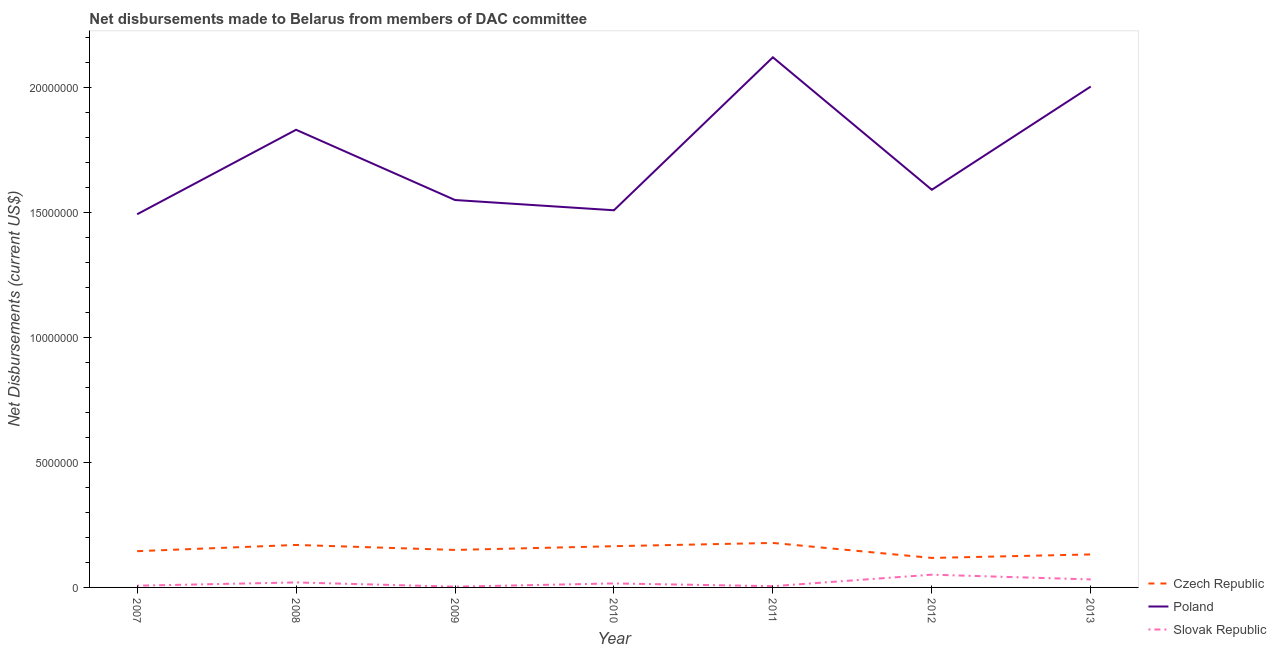How many different coloured lines are there?
Provide a succinct answer. 3. Is the number of lines equal to the number of legend labels?
Keep it short and to the point. Yes. What is the net disbursements made by slovak republic in 2009?
Keep it short and to the point. 3.00e+04. Across all years, what is the maximum net disbursements made by czech republic?
Your answer should be very brief. 1.78e+06. Across all years, what is the minimum net disbursements made by czech republic?
Your answer should be very brief. 1.18e+06. In which year was the net disbursements made by poland maximum?
Keep it short and to the point. 2011. What is the total net disbursements made by slovak republic in the graph?
Make the answer very short. 1.34e+06. What is the difference between the net disbursements made by czech republic in 2008 and that in 2013?
Your answer should be very brief. 3.80e+05. What is the difference between the net disbursements made by slovak republic in 2012 and the net disbursements made by poland in 2011?
Provide a short and direct response. -2.07e+07. What is the average net disbursements made by slovak republic per year?
Offer a terse response. 1.91e+05. In the year 2011, what is the difference between the net disbursements made by slovak republic and net disbursements made by poland?
Keep it short and to the point. -2.12e+07. In how many years, is the net disbursements made by poland greater than 11000000 US$?
Provide a succinct answer. 7. What is the ratio of the net disbursements made by slovak republic in 2007 to that in 2013?
Your answer should be compact. 0.22. Is the net disbursements made by slovak republic in 2010 less than that in 2012?
Your response must be concise. Yes. What is the difference between the highest and the lowest net disbursements made by slovak republic?
Offer a very short reply. 4.80e+05. Is the sum of the net disbursements made by czech republic in 2007 and 2013 greater than the maximum net disbursements made by poland across all years?
Offer a terse response. No. Is it the case that in every year, the sum of the net disbursements made by czech republic and net disbursements made by poland is greater than the net disbursements made by slovak republic?
Your answer should be very brief. Yes. Is the net disbursements made by slovak republic strictly greater than the net disbursements made by poland over the years?
Provide a succinct answer. No. Is the net disbursements made by poland strictly less than the net disbursements made by czech republic over the years?
Keep it short and to the point. No. How many lines are there?
Your answer should be very brief. 3. What is the difference between two consecutive major ticks on the Y-axis?
Keep it short and to the point. 5.00e+06. Are the values on the major ticks of Y-axis written in scientific E-notation?
Make the answer very short. No. Does the graph contain any zero values?
Give a very brief answer. No. Does the graph contain grids?
Provide a succinct answer. No. How are the legend labels stacked?
Offer a very short reply. Vertical. What is the title of the graph?
Your response must be concise. Net disbursements made to Belarus from members of DAC committee. What is the label or title of the X-axis?
Provide a succinct answer. Year. What is the label or title of the Y-axis?
Provide a succinct answer. Net Disbursements (current US$). What is the Net Disbursements (current US$) in Czech Republic in 2007?
Offer a very short reply. 1.45e+06. What is the Net Disbursements (current US$) in Poland in 2007?
Provide a succinct answer. 1.49e+07. What is the Net Disbursements (current US$) in Slovak Republic in 2007?
Provide a succinct answer. 7.00e+04. What is the Net Disbursements (current US$) in Czech Republic in 2008?
Ensure brevity in your answer.  1.70e+06. What is the Net Disbursements (current US$) in Poland in 2008?
Keep it short and to the point. 1.83e+07. What is the Net Disbursements (current US$) in Czech Republic in 2009?
Your response must be concise. 1.50e+06. What is the Net Disbursements (current US$) in Poland in 2009?
Offer a terse response. 1.55e+07. What is the Net Disbursements (current US$) of Slovak Republic in 2009?
Your answer should be compact. 3.00e+04. What is the Net Disbursements (current US$) in Czech Republic in 2010?
Provide a succinct answer. 1.65e+06. What is the Net Disbursements (current US$) in Poland in 2010?
Your answer should be very brief. 1.51e+07. What is the Net Disbursements (current US$) of Slovak Republic in 2010?
Give a very brief answer. 1.60e+05. What is the Net Disbursements (current US$) in Czech Republic in 2011?
Provide a succinct answer. 1.78e+06. What is the Net Disbursements (current US$) in Poland in 2011?
Provide a succinct answer. 2.12e+07. What is the Net Disbursements (current US$) of Czech Republic in 2012?
Provide a short and direct response. 1.18e+06. What is the Net Disbursements (current US$) of Poland in 2012?
Provide a short and direct response. 1.59e+07. What is the Net Disbursements (current US$) of Slovak Republic in 2012?
Make the answer very short. 5.10e+05. What is the Net Disbursements (current US$) in Czech Republic in 2013?
Provide a short and direct response. 1.32e+06. What is the Net Disbursements (current US$) in Poland in 2013?
Your answer should be compact. 2.00e+07. Across all years, what is the maximum Net Disbursements (current US$) in Czech Republic?
Keep it short and to the point. 1.78e+06. Across all years, what is the maximum Net Disbursements (current US$) of Poland?
Ensure brevity in your answer.  2.12e+07. Across all years, what is the maximum Net Disbursements (current US$) in Slovak Republic?
Provide a short and direct response. 5.10e+05. Across all years, what is the minimum Net Disbursements (current US$) of Czech Republic?
Keep it short and to the point. 1.18e+06. Across all years, what is the minimum Net Disbursements (current US$) of Poland?
Provide a succinct answer. 1.49e+07. What is the total Net Disbursements (current US$) of Czech Republic in the graph?
Provide a short and direct response. 1.06e+07. What is the total Net Disbursements (current US$) of Poland in the graph?
Provide a short and direct response. 1.21e+08. What is the total Net Disbursements (current US$) of Slovak Republic in the graph?
Your response must be concise. 1.34e+06. What is the difference between the Net Disbursements (current US$) of Czech Republic in 2007 and that in 2008?
Your answer should be compact. -2.50e+05. What is the difference between the Net Disbursements (current US$) in Poland in 2007 and that in 2008?
Provide a short and direct response. -3.38e+06. What is the difference between the Net Disbursements (current US$) in Czech Republic in 2007 and that in 2009?
Offer a very short reply. -5.00e+04. What is the difference between the Net Disbursements (current US$) of Poland in 2007 and that in 2009?
Your answer should be very brief. -5.70e+05. What is the difference between the Net Disbursements (current US$) in Poland in 2007 and that in 2010?
Your answer should be compact. -1.60e+05. What is the difference between the Net Disbursements (current US$) in Slovak Republic in 2007 and that in 2010?
Give a very brief answer. -9.00e+04. What is the difference between the Net Disbursements (current US$) in Czech Republic in 2007 and that in 2011?
Give a very brief answer. -3.30e+05. What is the difference between the Net Disbursements (current US$) of Poland in 2007 and that in 2011?
Your response must be concise. -6.28e+06. What is the difference between the Net Disbursements (current US$) in Slovak Republic in 2007 and that in 2011?
Your answer should be very brief. 2.00e+04. What is the difference between the Net Disbursements (current US$) in Poland in 2007 and that in 2012?
Keep it short and to the point. -9.80e+05. What is the difference between the Net Disbursements (current US$) in Slovak Republic in 2007 and that in 2012?
Provide a succinct answer. -4.40e+05. What is the difference between the Net Disbursements (current US$) of Czech Republic in 2007 and that in 2013?
Ensure brevity in your answer.  1.30e+05. What is the difference between the Net Disbursements (current US$) in Poland in 2007 and that in 2013?
Your answer should be compact. -5.11e+06. What is the difference between the Net Disbursements (current US$) in Slovak Republic in 2007 and that in 2013?
Your answer should be very brief. -2.50e+05. What is the difference between the Net Disbursements (current US$) in Poland in 2008 and that in 2009?
Offer a terse response. 2.81e+06. What is the difference between the Net Disbursements (current US$) of Poland in 2008 and that in 2010?
Your answer should be very brief. 3.22e+06. What is the difference between the Net Disbursements (current US$) in Czech Republic in 2008 and that in 2011?
Ensure brevity in your answer.  -8.00e+04. What is the difference between the Net Disbursements (current US$) of Poland in 2008 and that in 2011?
Your answer should be very brief. -2.90e+06. What is the difference between the Net Disbursements (current US$) of Czech Republic in 2008 and that in 2012?
Ensure brevity in your answer.  5.20e+05. What is the difference between the Net Disbursements (current US$) in Poland in 2008 and that in 2012?
Your answer should be compact. 2.40e+06. What is the difference between the Net Disbursements (current US$) of Slovak Republic in 2008 and that in 2012?
Ensure brevity in your answer.  -3.10e+05. What is the difference between the Net Disbursements (current US$) of Poland in 2008 and that in 2013?
Your answer should be very brief. -1.73e+06. What is the difference between the Net Disbursements (current US$) in Slovak Republic in 2008 and that in 2013?
Make the answer very short. -1.20e+05. What is the difference between the Net Disbursements (current US$) in Czech Republic in 2009 and that in 2010?
Keep it short and to the point. -1.50e+05. What is the difference between the Net Disbursements (current US$) of Poland in 2009 and that in 2010?
Make the answer very short. 4.10e+05. What is the difference between the Net Disbursements (current US$) in Czech Republic in 2009 and that in 2011?
Offer a very short reply. -2.80e+05. What is the difference between the Net Disbursements (current US$) of Poland in 2009 and that in 2011?
Make the answer very short. -5.71e+06. What is the difference between the Net Disbursements (current US$) of Czech Republic in 2009 and that in 2012?
Your answer should be very brief. 3.20e+05. What is the difference between the Net Disbursements (current US$) in Poland in 2009 and that in 2012?
Provide a short and direct response. -4.10e+05. What is the difference between the Net Disbursements (current US$) of Slovak Republic in 2009 and that in 2012?
Offer a terse response. -4.80e+05. What is the difference between the Net Disbursements (current US$) in Poland in 2009 and that in 2013?
Keep it short and to the point. -4.54e+06. What is the difference between the Net Disbursements (current US$) of Poland in 2010 and that in 2011?
Your answer should be very brief. -6.12e+06. What is the difference between the Net Disbursements (current US$) in Slovak Republic in 2010 and that in 2011?
Make the answer very short. 1.10e+05. What is the difference between the Net Disbursements (current US$) of Poland in 2010 and that in 2012?
Make the answer very short. -8.20e+05. What is the difference between the Net Disbursements (current US$) of Slovak Republic in 2010 and that in 2012?
Keep it short and to the point. -3.50e+05. What is the difference between the Net Disbursements (current US$) in Czech Republic in 2010 and that in 2013?
Provide a short and direct response. 3.30e+05. What is the difference between the Net Disbursements (current US$) of Poland in 2010 and that in 2013?
Your response must be concise. -4.95e+06. What is the difference between the Net Disbursements (current US$) in Czech Republic in 2011 and that in 2012?
Offer a very short reply. 6.00e+05. What is the difference between the Net Disbursements (current US$) of Poland in 2011 and that in 2012?
Your answer should be very brief. 5.30e+06. What is the difference between the Net Disbursements (current US$) in Slovak Republic in 2011 and that in 2012?
Offer a terse response. -4.60e+05. What is the difference between the Net Disbursements (current US$) in Poland in 2011 and that in 2013?
Your answer should be compact. 1.17e+06. What is the difference between the Net Disbursements (current US$) in Poland in 2012 and that in 2013?
Provide a succinct answer. -4.13e+06. What is the difference between the Net Disbursements (current US$) of Czech Republic in 2007 and the Net Disbursements (current US$) of Poland in 2008?
Provide a short and direct response. -1.69e+07. What is the difference between the Net Disbursements (current US$) in Czech Republic in 2007 and the Net Disbursements (current US$) in Slovak Republic in 2008?
Your answer should be compact. 1.25e+06. What is the difference between the Net Disbursements (current US$) in Poland in 2007 and the Net Disbursements (current US$) in Slovak Republic in 2008?
Keep it short and to the point. 1.47e+07. What is the difference between the Net Disbursements (current US$) in Czech Republic in 2007 and the Net Disbursements (current US$) in Poland in 2009?
Your answer should be compact. -1.40e+07. What is the difference between the Net Disbursements (current US$) in Czech Republic in 2007 and the Net Disbursements (current US$) in Slovak Republic in 2009?
Provide a short and direct response. 1.42e+06. What is the difference between the Net Disbursements (current US$) of Poland in 2007 and the Net Disbursements (current US$) of Slovak Republic in 2009?
Give a very brief answer. 1.49e+07. What is the difference between the Net Disbursements (current US$) in Czech Republic in 2007 and the Net Disbursements (current US$) in Poland in 2010?
Provide a short and direct response. -1.36e+07. What is the difference between the Net Disbursements (current US$) of Czech Republic in 2007 and the Net Disbursements (current US$) of Slovak Republic in 2010?
Keep it short and to the point. 1.29e+06. What is the difference between the Net Disbursements (current US$) in Poland in 2007 and the Net Disbursements (current US$) in Slovak Republic in 2010?
Ensure brevity in your answer.  1.48e+07. What is the difference between the Net Disbursements (current US$) of Czech Republic in 2007 and the Net Disbursements (current US$) of Poland in 2011?
Your response must be concise. -1.98e+07. What is the difference between the Net Disbursements (current US$) of Czech Republic in 2007 and the Net Disbursements (current US$) of Slovak Republic in 2011?
Offer a terse response. 1.40e+06. What is the difference between the Net Disbursements (current US$) of Poland in 2007 and the Net Disbursements (current US$) of Slovak Republic in 2011?
Offer a terse response. 1.49e+07. What is the difference between the Net Disbursements (current US$) of Czech Republic in 2007 and the Net Disbursements (current US$) of Poland in 2012?
Give a very brief answer. -1.45e+07. What is the difference between the Net Disbursements (current US$) of Czech Republic in 2007 and the Net Disbursements (current US$) of Slovak Republic in 2012?
Provide a succinct answer. 9.40e+05. What is the difference between the Net Disbursements (current US$) of Poland in 2007 and the Net Disbursements (current US$) of Slovak Republic in 2012?
Provide a short and direct response. 1.44e+07. What is the difference between the Net Disbursements (current US$) of Czech Republic in 2007 and the Net Disbursements (current US$) of Poland in 2013?
Your response must be concise. -1.86e+07. What is the difference between the Net Disbursements (current US$) in Czech Republic in 2007 and the Net Disbursements (current US$) in Slovak Republic in 2013?
Offer a very short reply. 1.13e+06. What is the difference between the Net Disbursements (current US$) of Poland in 2007 and the Net Disbursements (current US$) of Slovak Republic in 2013?
Give a very brief answer. 1.46e+07. What is the difference between the Net Disbursements (current US$) in Czech Republic in 2008 and the Net Disbursements (current US$) in Poland in 2009?
Keep it short and to the point. -1.38e+07. What is the difference between the Net Disbursements (current US$) in Czech Republic in 2008 and the Net Disbursements (current US$) in Slovak Republic in 2009?
Offer a very short reply. 1.67e+06. What is the difference between the Net Disbursements (current US$) of Poland in 2008 and the Net Disbursements (current US$) of Slovak Republic in 2009?
Ensure brevity in your answer.  1.83e+07. What is the difference between the Net Disbursements (current US$) of Czech Republic in 2008 and the Net Disbursements (current US$) of Poland in 2010?
Give a very brief answer. -1.34e+07. What is the difference between the Net Disbursements (current US$) of Czech Republic in 2008 and the Net Disbursements (current US$) of Slovak Republic in 2010?
Give a very brief answer. 1.54e+06. What is the difference between the Net Disbursements (current US$) in Poland in 2008 and the Net Disbursements (current US$) in Slovak Republic in 2010?
Provide a succinct answer. 1.82e+07. What is the difference between the Net Disbursements (current US$) of Czech Republic in 2008 and the Net Disbursements (current US$) of Poland in 2011?
Provide a succinct answer. -1.95e+07. What is the difference between the Net Disbursements (current US$) in Czech Republic in 2008 and the Net Disbursements (current US$) in Slovak Republic in 2011?
Give a very brief answer. 1.65e+06. What is the difference between the Net Disbursements (current US$) of Poland in 2008 and the Net Disbursements (current US$) of Slovak Republic in 2011?
Give a very brief answer. 1.83e+07. What is the difference between the Net Disbursements (current US$) in Czech Republic in 2008 and the Net Disbursements (current US$) in Poland in 2012?
Your answer should be very brief. -1.42e+07. What is the difference between the Net Disbursements (current US$) in Czech Republic in 2008 and the Net Disbursements (current US$) in Slovak Republic in 2012?
Ensure brevity in your answer.  1.19e+06. What is the difference between the Net Disbursements (current US$) in Poland in 2008 and the Net Disbursements (current US$) in Slovak Republic in 2012?
Your answer should be compact. 1.78e+07. What is the difference between the Net Disbursements (current US$) of Czech Republic in 2008 and the Net Disbursements (current US$) of Poland in 2013?
Provide a succinct answer. -1.83e+07. What is the difference between the Net Disbursements (current US$) of Czech Republic in 2008 and the Net Disbursements (current US$) of Slovak Republic in 2013?
Give a very brief answer. 1.38e+06. What is the difference between the Net Disbursements (current US$) in Poland in 2008 and the Net Disbursements (current US$) in Slovak Republic in 2013?
Keep it short and to the point. 1.80e+07. What is the difference between the Net Disbursements (current US$) of Czech Republic in 2009 and the Net Disbursements (current US$) of Poland in 2010?
Offer a very short reply. -1.36e+07. What is the difference between the Net Disbursements (current US$) in Czech Republic in 2009 and the Net Disbursements (current US$) in Slovak Republic in 2010?
Your answer should be very brief. 1.34e+06. What is the difference between the Net Disbursements (current US$) in Poland in 2009 and the Net Disbursements (current US$) in Slovak Republic in 2010?
Your response must be concise. 1.53e+07. What is the difference between the Net Disbursements (current US$) of Czech Republic in 2009 and the Net Disbursements (current US$) of Poland in 2011?
Give a very brief answer. -1.97e+07. What is the difference between the Net Disbursements (current US$) in Czech Republic in 2009 and the Net Disbursements (current US$) in Slovak Republic in 2011?
Your response must be concise. 1.45e+06. What is the difference between the Net Disbursements (current US$) in Poland in 2009 and the Net Disbursements (current US$) in Slovak Republic in 2011?
Give a very brief answer. 1.54e+07. What is the difference between the Net Disbursements (current US$) of Czech Republic in 2009 and the Net Disbursements (current US$) of Poland in 2012?
Your response must be concise. -1.44e+07. What is the difference between the Net Disbursements (current US$) of Czech Republic in 2009 and the Net Disbursements (current US$) of Slovak Republic in 2012?
Give a very brief answer. 9.90e+05. What is the difference between the Net Disbursements (current US$) of Poland in 2009 and the Net Disbursements (current US$) of Slovak Republic in 2012?
Your answer should be very brief. 1.50e+07. What is the difference between the Net Disbursements (current US$) in Czech Republic in 2009 and the Net Disbursements (current US$) in Poland in 2013?
Ensure brevity in your answer.  -1.85e+07. What is the difference between the Net Disbursements (current US$) in Czech Republic in 2009 and the Net Disbursements (current US$) in Slovak Republic in 2013?
Your answer should be compact. 1.18e+06. What is the difference between the Net Disbursements (current US$) in Poland in 2009 and the Net Disbursements (current US$) in Slovak Republic in 2013?
Your answer should be compact. 1.52e+07. What is the difference between the Net Disbursements (current US$) in Czech Republic in 2010 and the Net Disbursements (current US$) in Poland in 2011?
Your response must be concise. -1.96e+07. What is the difference between the Net Disbursements (current US$) in Czech Republic in 2010 and the Net Disbursements (current US$) in Slovak Republic in 2011?
Offer a terse response. 1.60e+06. What is the difference between the Net Disbursements (current US$) of Poland in 2010 and the Net Disbursements (current US$) of Slovak Republic in 2011?
Provide a short and direct response. 1.50e+07. What is the difference between the Net Disbursements (current US$) in Czech Republic in 2010 and the Net Disbursements (current US$) in Poland in 2012?
Your answer should be compact. -1.43e+07. What is the difference between the Net Disbursements (current US$) in Czech Republic in 2010 and the Net Disbursements (current US$) in Slovak Republic in 2012?
Your answer should be compact. 1.14e+06. What is the difference between the Net Disbursements (current US$) in Poland in 2010 and the Net Disbursements (current US$) in Slovak Republic in 2012?
Your answer should be compact. 1.46e+07. What is the difference between the Net Disbursements (current US$) of Czech Republic in 2010 and the Net Disbursements (current US$) of Poland in 2013?
Ensure brevity in your answer.  -1.84e+07. What is the difference between the Net Disbursements (current US$) in Czech Republic in 2010 and the Net Disbursements (current US$) in Slovak Republic in 2013?
Ensure brevity in your answer.  1.33e+06. What is the difference between the Net Disbursements (current US$) in Poland in 2010 and the Net Disbursements (current US$) in Slovak Republic in 2013?
Your answer should be compact. 1.48e+07. What is the difference between the Net Disbursements (current US$) of Czech Republic in 2011 and the Net Disbursements (current US$) of Poland in 2012?
Provide a succinct answer. -1.41e+07. What is the difference between the Net Disbursements (current US$) in Czech Republic in 2011 and the Net Disbursements (current US$) in Slovak Republic in 2012?
Your answer should be compact. 1.27e+06. What is the difference between the Net Disbursements (current US$) of Poland in 2011 and the Net Disbursements (current US$) of Slovak Republic in 2012?
Provide a succinct answer. 2.07e+07. What is the difference between the Net Disbursements (current US$) in Czech Republic in 2011 and the Net Disbursements (current US$) in Poland in 2013?
Keep it short and to the point. -1.83e+07. What is the difference between the Net Disbursements (current US$) of Czech Republic in 2011 and the Net Disbursements (current US$) of Slovak Republic in 2013?
Offer a terse response. 1.46e+06. What is the difference between the Net Disbursements (current US$) in Poland in 2011 and the Net Disbursements (current US$) in Slovak Republic in 2013?
Offer a very short reply. 2.09e+07. What is the difference between the Net Disbursements (current US$) in Czech Republic in 2012 and the Net Disbursements (current US$) in Poland in 2013?
Make the answer very short. -1.89e+07. What is the difference between the Net Disbursements (current US$) of Czech Republic in 2012 and the Net Disbursements (current US$) of Slovak Republic in 2013?
Your answer should be compact. 8.60e+05. What is the difference between the Net Disbursements (current US$) of Poland in 2012 and the Net Disbursements (current US$) of Slovak Republic in 2013?
Make the answer very short. 1.56e+07. What is the average Net Disbursements (current US$) in Czech Republic per year?
Offer a terse response. 1.51e+06. What is the average Net Disbursements (current US$) in Poland per year?
Your answer should be compact. 1.73e+07. What is the average Net Disbursements (current US$) in Slovak Republic per year?
Provide a succinct answer. 1.91e+05. In the year 2007, what is the difference between the Net Disbursements (current US$) in Czech Republic and Net Disbursements (current US$) in Poland?
Your answer should be very brief. -1.35e+07. In the year 2007, what is the difference between the Net Disbursements (current US$) in Czech Republic and Net Disbursements (current US$) in Slovak Republic?
Give a very brief answer. 1.38e+06. In the year 2007, what is the difference between the Net Disbursements (current US$) in Poland and Net Disbursements (current US$) in Slovak Republic?
Make the answer very short. 1.49e+07. In the year 2008, what is the difference between the Net Disbursements (current US$) of Czech Republic and Net Disbursements (current US$) of Poland?
Keep it short and to the point. -1.66e+07. In the year 2008, what is the difference between the Net Disbursements (current US$) of Czech Republic and Net Disbursements (current US$) of Slovak Republic?
Offer a very short reply. 1.50e+06. In the year 2008, what is the difference between the Net Disbursements (current US$) of Poland and Net Disbursements (current US$) of Slovak Republic?
Your answer should be very brief. 1.81e+07. In the year 2009, what is the difference between the Net Disbursements (current US$) in Czech Republic and Net Disbursements (current US$) in Poland?
Provide a short and direct response. -1.40e+07. In the year 2009, what is the difference between the Net Disbursements (current US$) of Czech Republic and Net Disbursements (current US$) of Slovak Republic?
Ensure brevity in your answer.  1.47e+06. In the year 2009, what is the difference between the Net Disbursements (current US$) in Poland and Net Disbursements (current US$) in Slovak Republic?
Your response must be concise. 1.55e+07. In the year 2010, what is the difference between the Net Disbursements (current US$) in Czech Republic and Net Disbursements (current US$) in Poland?
Your answer should be very brief. -1.34e+07. In the year 2010, what is the difference between the Net Disbursements (current US$) in Czech Republic and Net Disbursements (current US$) in Slovak Republic?
Provide a short and direct response. 1.49e+06. In the year 2010, what is the difference between the Net Disbursements (current US$) of Poland and Net Disbursements (current US$) of Slovak Republic?
Give a very brief answer. 1.49e+07. In the year 2011, what is the difference between the Net Disbursements (current US$) of Czech Republic and Net Disbursements (current US$) of Poland?
Provide a succinct answer. -1.94e+07. In the year 2011, what is the difference between the Net Disbursements (current US$) in Czech Republic and Net Disbursements (current US$) in Slovak Republic?
Your response must be concise. 1.73e+06. In the year 2011, what is the difference between the Net Disbursements (current US$) of Poland and Net Disbursements (current US$) of Slovak Republic?
Ensure brevity in your answer.  2.12e+07. In the year 2012, what is the difference between the Net Disbursements (current US$) in Czech Republic and Net Disbursements (current US$) in Poland?
Ensure brevity in your answer.  -1.47e+07. In the year 2012, what is the difference between the Net Disbursements (current US$) in Czech Republic and Net Disbursements (current US$) in Slovak Republic?
Offer a terse response. 6.70e+05. In the year 2012, what is the difference between the Net Disbursements (current US$) of Poland and Net Disbursements (current US$) of Slovak Republic?
Offer a very short reply. 1.54e+07. In the year 2013, what is the difference between the Net Disbursements (current US$) in Czech Republic and Net Disbursements (current US$) in Poland?
Make the answer very short. -1.87e+07. In the year 2013, what is the difference between the Net Disbursements (current US$) of Czech Republic and Net Disbursements (current US$) of Slovak Republic?
Your response must be concise. 1.00e+06. In the year 2013, what is the difference between the Net Disbursements (current US$) of Poland and Net Disbursements (current US$) of Slovak Republic?
Offer a terse response. 1.97e+07. What is the ratio of the Net Disbursements (current US$) of Czech Republic in 2007 to that in 2008?
Ensure brevity in your answer.  0.85. What is the ratio of the Net Disbursements (current US$) in Poland in 2007 to that in 2008?
Keep it short and to the point. 0.82. What is the ratio of the Net Disbursements (current US$) in Czech Republic in 2007 to that in 2009?
Keep it short and to the point. 0.97. What is the ratio of the Net Disbursements (current US$) in Poland in 2007 to that in 2009?
Provide a succinct answer. 0.96. What is the ratio of the Net Disbursements (current US$) in Slovak Republic in 2007 to that in 2009?
Your answer should be compact. 2.33. What is the ratio of the Net Disbursements (current US$) of Czech Republic in 2007 to that in 2010?
Ensure brevity in your answer.  0.88. What is the ratio of the Net Disbursements (current US$) of Slovak Republic in 2007 to that in 2010?
Provide a succinct answer. 0.44. What is the ratio of the Net Disbursements (current US$) in Czech Republic in 2007 to that in 2011?
Provide a succinct answer. 0.81. What is the ratio of the Net Disbursements (current US$) in Poland in 2007 to that in 2011?
Your answer should be compact. 0.7. What is the ratio of the Net Disbursements (current US$) in Czech Republic in 2007 to that in 2012?
Provide a succinct answer. 1.23. What is the ratio of the Net Disbursements (current US$) of Poland in 2007 to that in 2012?
Provide a short and direct response. 0.94. What is the ratio of the Net Disbursements (current US$) in Slovak Republic in 2007 to that in 2012?
Provide a short and direct response. 0.14. What is the ratio of the Net Disbursements (current US$) in Czech Republic in 2007 to that in 2013?
Your answer should be compact. 1.1. What is the ratio of the Net Disbursements (current US$) in Poland in 2007 to that in 2013?
Provide a short and direct response. 0.74. What is the ratio of the Net Disbursements (current US$) in Slovak Republic in 2007 to that in 2013?
Offer a very short reply. 0.22. What is the ratio of the Net Disbursements (current US$) in Czech Republic in 2008 to that in 2009?
Offer a very short reply. 1.13. What is the ratio of the Net Disbursements (current US$) of Poland in 2008 to that in 2009?
Make the answer very short. 1.18. What is the ratio of the Net Disbursements (current US$) in Slovak Republic in 2008 to that in 2009?
Ensure brevity in your answer.  6.67. What is the ratio of the Net Disbursements (current US$) of Czech Republic in 2008 to that in 2010?
Make the answer very short. 1.03. What is the ratio of the Net Disbursements (current US$) in Poland in 2008 to that in 2010?
Give a very brief answer. 1.21. What is the ratio of the Net Disbursements (current US$) in Czech Republic in 2008 to that in 2011?
Offer a very short reply. 0.96. What is the ratio of the Net Disbursements (current US$) of Poland in 2008 to that in 2011?
Offer a terse response. 0.86. What is the ratio of the Net Disbursements (current US$) of Slovak Republic in 2008 to that in 2011?
Provide a short and direct response. 4. What is the ratio of the Net Disbursements (current US$) of Czech Republic in 2008 to that in 2012?
Make the answer very short. 1.44. What is the ratio of the Net Disbursements (current US$) in Poland in 2008 to that in 2012?
Provide a succinct answer. 1.15. What is the ratio of the Net Disbursements (current US$) in Slovak Republic in 2008 to that in 2012?
Keep it short and to the point. 0.39. What is the ratio of the Net Disbursements (current US$) of Czech Republic in 2008 to that in 2013?
Your answer should be compact. 1.29. What is the ratio of the Net Disbursements (current US$) in Poland in 2008 to that in 2013?
Your answer should be compact. 0.91. What is the ratio of the Net Disbursements (current US$) in Slovak Republic in 2008 to that in 2013?
Keep it short and to the point. 0.62. What is the ratio of the Net Disbursements (current US$) in Poland in 2009 to that in 2010?
Provide a succinct answer. 1.03. What is the ratio of the Net Disbursements (current US$) in Slovak Republic in 2009 to that in 2010?
Offer a very short reply. 0.19. What is the ratio of the Net Disbursements (current US$) in Czech Republic in 2009 to that in 2011?
Offer a very short reply. 0.84. What is the ratio of the Net Disbursements (current US$) in Poland in 2009 to that in 2011?
Your answer should be compact. 0.73. What is the ratio of the Net Disbursements (current US$) of Czech Republic in 2009 to that in 2012?
Offer a very short reply. 1.27. What is the ratio of the Net Disbursements (current US$) of Poland in 2009 to that in 2012?
Your response must be concise. 0.97. What is the ratio of the Net Disbursements (current US$) of Slovak Republic in 2009 to that in 2012?
Provide a succinct answer. 0.06. What is the ratio of the Net Disbursements (current US$) in Czech Republic in 2009 to that in 2013?
Offer a terse response. 1.14. What is the ratio of the Net Disbursements (current US$) in Poland in 2009 to that in 2013?
Give a very brief answer. 0.77. What is the ratio of the Net Disbursements (current US$) of Slovak Republic in 2009 to that in 2013?
Your answer should be compact. 0.09. What is the ratio of the Net Disbursements (current US$) of Czech Republic in 2010 to that in 2011?
Make the answer very short. 0.93. What is the ratio of the Net Disbursements (current US$) in Poland in 2010 to that in 2011?
Your answer should be compact. 0.71. What is the ratio of the Net Disbursements (current US$) of Czech Republic in 2010 to that in 2012?
Your response must be concise. 1.4. What is the ratio of the Net Disbursements (current US$) of Poland in 2010 to that in 2012?
Offer a terse response. 0.95. What is the ratio of the Net Disbursements (current US$) in Slovak Republic in 2010 to that in 2012?
Provide a succinct answer. 0.31. What is the ratio of the Net Disbursements (current US$) of Poland in 2010 to that in 2013?
Offer a very short reply. 0.75. What is the ratio of the Net Disbursements (current US$) in Czech Republic in 2011 to that in 2012?
Offer a terse response. 1.51. What is the ratio of the Net Disbursements (current US$) of Poland in 2011 to that in 2012?
Your answer should be compact. 1.33. What is the ratio of the Net Disbursements (current US$) of Slovak Republic in 2011 to that in 2012?
Offer a terse response. 0.1. What is the ratio of the Net Disbursements (current US$) in Czech Republic in 2011 to that in 2013?
Provide a short and direct response. 1.35. What is the ratio of the Net Disbursements (current US$) of Poland in 2011 to that in 2013?
Your response must be concise. 1.06. What is the ratio of the Net Disbursements (current US$) in Slovak Republic in 2011 to that in 2013?
Provide a succinct answer. 0.16. What is the ratio of the Net Disbursements (current US$) in Czech Republic in 2012 to that in 2013?
Your answer should be compact. 0.89. What is the ratio of the Net Disbursements (current US$) of Poland in 2012 to that in 2013?
Provide a succinct answer. 0.79. What is the ratio of the Net Disbursements (current US$) in Slovak Republic in 2012 to that in 2013?
Provide a succinct answer. 1.59. What is the difference between the highest and the second highest Net Disbursements (current US$) of Czech Republic?
Ensure brevity in your answer.  8.00e+04. What is the difference between the highest and the second highest Net Disbursements (current US$) in Poland?
Offer a very short reply. 1.17e+06. What is the difference between the highest and the second highest Net Disbursements (current US$) in Slovak Republic?
Your response must be concise. 1.90e+05. What is the difference between the highest and the lowest Net Disbursements (current US$) of Poland?
Provide a succinct answer. 6.28e+06. What is the difference between the highest and the lowest Net Disbursements (current US$) in Slovak Republic?
Ensure brevity in your answer.  4.80e+05. 